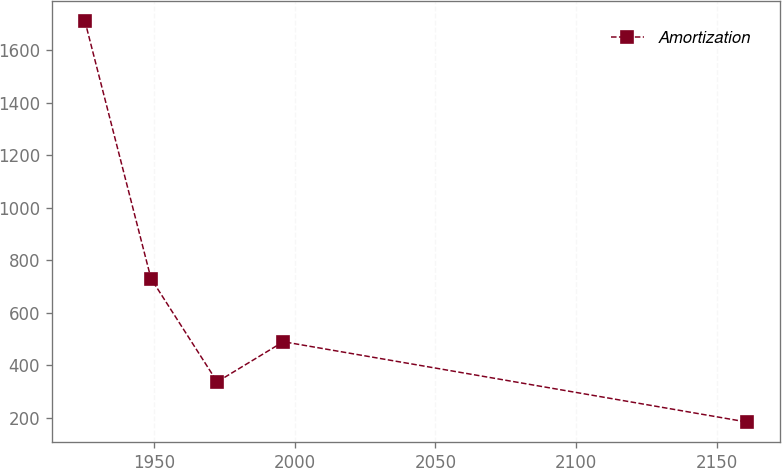Convert chart. <chart><loc_0><loc_0><loc_500><loc_500><line_chart><ecel><fcel>Amortization<nl><fcel>1925.48<fcel>1713.37<nl><fcel>1948.99<fcel>730.81<nl><fcel>1972.5<fcel>337.22<nl><fcel>1996.01<fcel>490.13<nl><fcel>2160.62<fcel>184.31<nl></chart> 